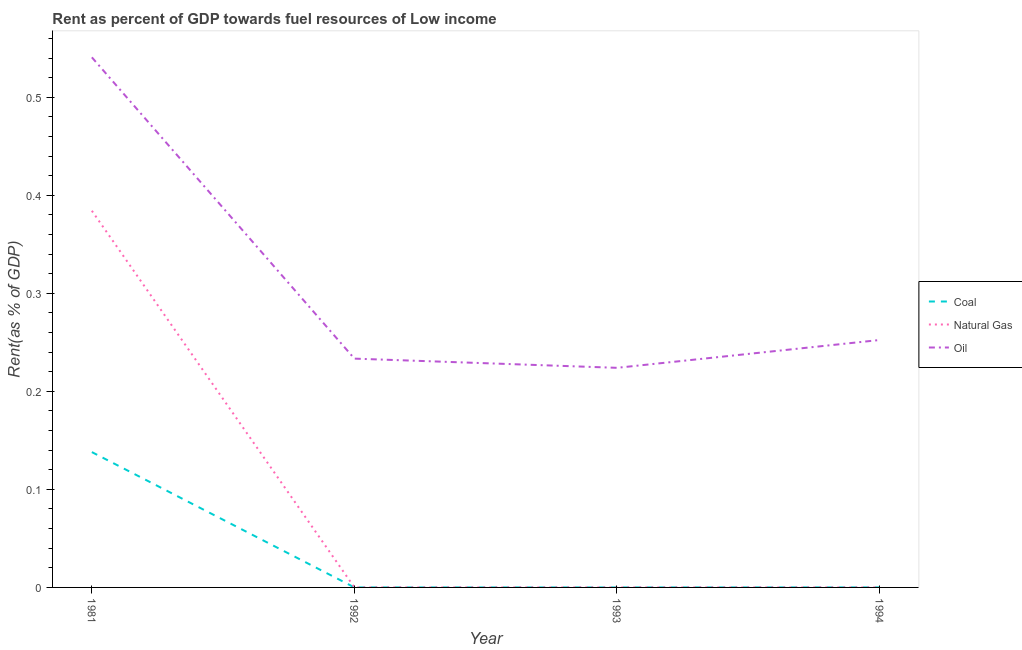How many different coloured lines are there?
Your answer should be compact. 3. What is the rent towards oil in 1993?
Provide a short and direct response. 0.22. Across all years, what is the maximum rent towards natural gas?
Give a very brief answer. 0.38. Across all years, what is the minimum rent towards natural gas?
Your response must be concise. 1.65939262527339e-5. In which year was the rent towards oil maximum?
Give a very brief answer. 1981. What is the total rent towards oil in the graph?
Your answer should be compact. 1.25. What is the difference between the rent towards oil in 1993 and that in 1994?
Offer a terse response. -0.03. What is the difference between the rent towards coal in 1994 and the rent towards natural gas in 1993?
Provide a short and direct response. 2.28651893067039e-5. What is the average rent towards natural gas per year?
Give a very brief answer. 0.1. In the year 1981, what is the difference between the rent towards oil and rent towards coal?
Provide a short and direct response. 0.4. What is the ratio of the rent towards natural gas in 1992 to that in 1994?
Offer a very short reply. 1. What is the difference between the highest and the second highest rent towards coal?
Offer a very short reply. 0.14. What is the difference between the highest and the lowest rent towards coal?
Your response must be concise. 0.14. In how many years, is the rent towards natural gas greater than the average rent towards natural gas taken over all years?
Your response must be concise. 1. Is the sum of the rent towards coal in 1992 and 1993 greater than the maximum rent towards natural gas across all years?
Your response must be concise. No. Is the rent towards oil strictly greater than the rent towards natural gas over the years?
Keep it short and to the point. Yes. How many lines are there?
Your answer should be very brief. 3. Does the graph contain grids?
Keep it short and to the point. No. How many legend labels are there?
Offer a very short reply. 3. What is the title of the graph?
Give a very brief answer. Rent as percent of GDP towards fuel resources of Low income. What is the label or title of the Y-axis?
Give a very brief answer. Rent(as % of GDP). What is the Rent(as % of GDP) of Coal in 1981?
Give a very brief answer. 0.14. What is the Rent(as % of GDP) in Natural Gas in 1981?
Your answer should be very brief. 0.38. What is the Rent(as % of GDP) in Oil in 1981?
Give a very brief answer. 0.54. What is the Rent(as % of GDP) in Coal in 1992?
Ensure brevity in your answer.  1.2205342104036e-5. What is the Rent(as % of GDP) in Natural Gas in 1992?
Ensure brevity in your answer.  1.65939262527339e-5. What is the Rent(as % of GDP) of Oil in 1992?
Provide a short and direct response. 0.23. What is the Rent(as % of GDP) in Coal in 1993?
Your response must be concise. 8.23532495624202e-6. What is the Rent(as % of GDP) in Natural Gas in 1993?
Offer a very short reply. 1.98169078129084e-5. What is the Rent(as % of GDP) of Oil in 1993?
Ensure brevity in your answer.  0.22. What is the Rent(as % of GDP) of Coal in 1994?
Provide a succinct answer. 4.26820971196123e-5. What is the Rent(as % of GDP) in Natural Gas in 1994?
Give a very brief answer. 1.66764618261871e-5. What is the Rent(as % of GDP) in Oil in 1994?
Your answer should be compact. 0.25. Across all years, what is the maximum Rent(as % of GDP) in Coal?
Provide a succinct answer. 0.14. Across all years, what is the maximum Rent(as % of GDP) of Natural Gas?
Give a very brief answer. 0.38. Across all years, what is the maximum Rent(as % of GDP) of Oil?
Your answer should be compact. 0.54. Across all years, what is the minimum Rent(as % of GDP) in Coal?
Keep it short and to the point. 8.23532495624202e-6. Across all years, what is the minimum Rent(as % of GDP) of Natural Gas?
Offer a very short reply. 1.65939262527339e-5. Across all years, what is the minimum Rent(as % of GDP) of Oil?
Offer a terse response. 0.22. What is the total Rent(as % of GDP) of Coal in the graph?
Offer a very short reply. 0.14. What is the total Rent(as % of GDP) of Natural Gas in the graph?
Keep it short and to the point. 0.38. What is the total Rent(as % of GDP) of Oil in the graph?
Your response must be concise. 1.25. What is the difference between the Rent(as % of GDP) in Coal in 1981 and that in 1992?
Your answer should be very brief. 0.14. What is the difference between the Rent(as % of GDP) of Natural Gas in 1981 and that in 1992?
Keep it short and to the point. 0.38. What is the difference between the Rent(as % of GDP) in Oil in 1981 and that in 1992?
Provide a succinct answer. 0.31. What is the difference between the Rent(as % of GDP) in Coal in 1981 and that in 1993?
Provide a succinct answer. 0.14. What is the difference between the Rent(as % of GDP) in Natural Gas in 1981 and that in 1993?
Offer a terse response. 0.38. What is the difference between the Rent(as % of GDP) of Oil in 1981 and that in 1993?
Keep it short and to the point. 0.32. What is the difference between the Rent(as % of GDP) in Coal in 1981 and that in 1994?
Your answer should be very brief. 0.14. What is the difference between the Rent(as % of GDP) of Natural Gas in 1981 and that in 1994?
Offer a terse response. 0.38. What is the difference between the Rent(as % of GDP) in Oil in 1981 and that in 1994?
Your answer should be very brief. 0.29. What is the difference between the Rent(as % of GDP) in Coal in 1992 and that in 1993?
Your answer should be very brief. 0. What is the difference between the Rent(as % of GDP) of Natural Gas in 1992 and that in 1993?
Give a very brief answer. -0. What is the difference between the Rent(as % of GDP) of Oil in 1992 and that in 1993?
Ensure brevity in your answer.  0.01. What is the difference between the Rent(as % of GDP) of Oil in 1992 and that in 1994?
Give a very brief answer. -0.02. What is the difference between the Rent(as % of GDP) in Natural Gas in 1993 and that in 1994?
Offer a very short reply. 0. What is the difference between the Rent(as % of GDP) of Oil in 1993 and that in 1994?
Provide a succinct answer. -0.03. What is the difference between the Rent(as % of GDP) of Coal in 1981 and the Rent(as % of GDP) of Natural Gas in 1992?
Ensure brevity in your answer.  0.14. What is the difference between the Rent(as % of GDP) in Coal in 1981 and the Rent(as % of GDP) in Oil in 1992?
Keep it short and to the point. -0.1. What is the difference between the Rent(as % of GDP) of Natural Gas in 1981 and the Rent(as % of GDP) of Oil in 1992?
Make the answer very short. 0.15. What is the difference between the Rent(as % of GDP) in Coal in 1981 and the Rent(as % of GDP) in Natural Gas in 1993?
Give a very brief answer. 0.14. What is the difference between the Rent(as % of GDP) in Coal in 1981 and the Rent(as % of GDP) in Oil in 1993?
Your answer should be compact. -0.09. What is the difference between the Rent(as % of GDP) of Natural Gas in 1981 and the Rent(as % of GDP) of Oil in 1993?
Offer a terse response. 0.16. What is the difference between the Rent(as % of GDP) of Coal in 1981 and the Rent(as % of GDP) of Natural Gas in 1994?
Offer a terse response. 0.14. What is the difference between the Rent(as % of GDP) in Coal in 1981 and the Rent(as % of GDP) in Oil in 1994?
Give a very brief answer. -0.11. What is the difference between the Rent(as % of GDP) in Natural Gas in 1981 and the Rent(as % of GDP) in Oil in 1994?
Your answer should be compact. 0.13. What is the difference between the Rent(as % of GDP) in Coal in 1992 and the Rent(as % of GDP) in Natural Gas in 1993?
Keep it short and to the point. -0. What is the difference between the Rent(as % of GDP) of Coal in 1992 and the Rent(as % of GDP) of Oil in 1993?
Your response must be concise. -0.22. What is the difference between the Rent(as % of GDP) in Natural Gas in 1992 and the Rent(as % of GDP) in Oil in 1993?
Keep it short and to the point. -0.22. What is the difference between the Rent(as % of GDP) of Coal in 1992 and the Rent(as % of GDP) of Oil in 1994?
Your response must be concise. -0.25. What is the difference between the Rent(as % of GDP) of Natural Gas in 1992 and the Rent(as % of GDP) of Oil in 1994?
Make the answer very short. -0.25. What is the difference between the Rent(as % of GDP) of Coal in 1993 and the Rent(as % of GDP) of Oil in 1994?
Provide a short and direct response. -0.25. What is the difference between the Rent(as % of GDP) in Natural Gas in 1993 and the Rent(as % of GDP) in Oil in 1994?
Make the answer very short. -0.25. What is the average Rent(as % of GDP) of Coal per year?
Provide a short and direct response. 0.03. What is the average Rent(as % of GDP) of Natural Gas per year?
Ensure brevity in your answer.  0.1. What is the average Rent(as % of GDP) in Oil per year?
Give a very brief answer. 0.31. In the year 1981, what is the difference between the Rent(as % of GDP) of Coal and Rent(as % of GDP) of Natural Gas?
Provide a succinct answer. -0.25. In the year 1981, what is the difference between the Rent(as % of GDP) of Coal and Rent(as % of GDP) of Oil?
Offer a terse response. -0.4. In the year 1981, what is the difference between the Rent(as % of GDP) of Natural Gas and Rent(as % of GDP) of Oil?
Ensure brevity in your answer.  -0.16. In the year 1992, what is the difference between the Rent(as % of GDP) of Coal and Rent(as % of GDP) of Oil?
Offer a very short reply. -0.23. In the year 1992, what is the difference between the Rent(as % of GDP) of Natural Gas and Rent(as % of GDP) of Oil?
Keep it short and to the point. -0.23. In the year 1993, what is the difference between the Rent(as % of GDP) of Coal and Rent(as % of GDP) of Natural Gas?
Provide a short and direct response. -0. In the year 1993, what is the difference between the Rent(as % of GDP) of Coal and Rent(as % of GDP) of Oil?
Offer a very short reply. -0.22. In the year 1993, what is the difference between the Rent(as % of GDP) in Natural Gas and Rent(as % of GDP) in Oil?
Provide a short and direct response. -0.22. In the year 1994, what is the difference between the Rent(as % of GDP) in Coal and Rent(as % of GDP) in Oil?
Provide a short and direct response. -0.25. In the year 1994, what is the difference between the Rent(as % of GDP) of Natural Gas and Rent(as % of GDP) of Oil?
Offer a terse response. -0.25. What is the ratio of the Rent(as % of GDP) in Coal in 1981 to that in 1992?
Your response must be concise. 1.13e+04. What is the ratio of the Rent(as % of GDP) of Natural Gas in 1981 to that in 1992?
Your answer should be compact. 2.32e+04. What is the ratio of the Rent(as % of GDP) of Oil in 1981 to that in 1992?
Keep it short and to the point. 2.32. What is the ratio of the Rent(as % of GDP) in Coal in 1981 to that in 1993?
Your answer should be very brief. 1.68e+04. What is the ratio of the Rent(as % of GDP) of Natural Gas in 1981 to that in 1993?
Your response must be concise. 1.94e+04. What is the ratio of the Rent(as % of GDP) of Oil in 1981 to that in 1993?
Keep it short and to the point. 2.41. What is the ratio of the Rent(as % of GDP) in Coal in 1981 to that in 1994?
Give a very brief answer. 3234.13. What is the ratio of the Rent(as % of GDP) of Natural Gas in 1981 to that in 1994?
Your answer should be very brief. 2.30e+04. What is the ratio of the Rent(as % of GDP) in Oil in 1981 to that in 1994?
Ensure brevity in your answer.  2.14. What is the ratio of the Rent(as % of GDP) in Coal in 1992 to that in 1993?
Give a very brief answer. 1.48. What is the ratio of the Rent(as % of GDP) of Natural Gas in 1992 to that in 1993?
Ensure brevity in your answer.  0.84. What is the ratio of the Rent(as % of GDP) in Oil in 1992 to that in 1993?
Your answer should be compact. 1.04. What is the ratio of the Rent(as % of GDP) of Coal in 1992 to that in 1994?
Your response must be concise. 0.29. What is the ratio of the Rent(as % of GDP) in Oil in 1992 to that in 1994?
Provide a short and direct response. 0.92. What is the ratio of the Rent(as % of GDP) in Coal in 1993 to that in 1994?
Provide a succinct answer. 0.19. What is the ratio of the Rent(as % of GDP) of Natural Gas in 1993 to that in 1994?
Your answer should be very brief. 1.19. What is the ratio of the Rent(as % of GDP) of Oil in 1993 to that in 1994?
Your response must be concise. 0.89. What is the difference between the highest and the second highest Rent(as % of GDP) of Coal?
Make the answer very short. 0.14. What is the difference between the highest and the second highest Rent(as % of GDP) in Natural Gas?
Ensure brevity in your answer.  0.38. What is the difference between the highest and the second highest Rent(as % of GDP) in Oil?
Ensure brevity in your answer.  0.29. What is the difference between the highest and the lowest Rent(as % of GDP) of Coal?
Your response must be concise. 0.14. What is the difference between the highest and the lowest Rent(as % of GDP) in Natural Gas?
Your answer should be very brief. 0.38. What is the difference between the highest and the lowest Rent(as % of GDP) of Oil?
Keep it short and to the point. 0.32. 